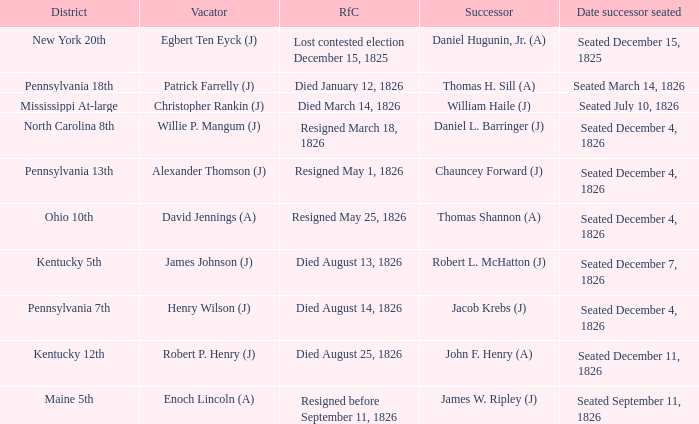Name the vacator for died august 13, 1826 James Johnson (J). 